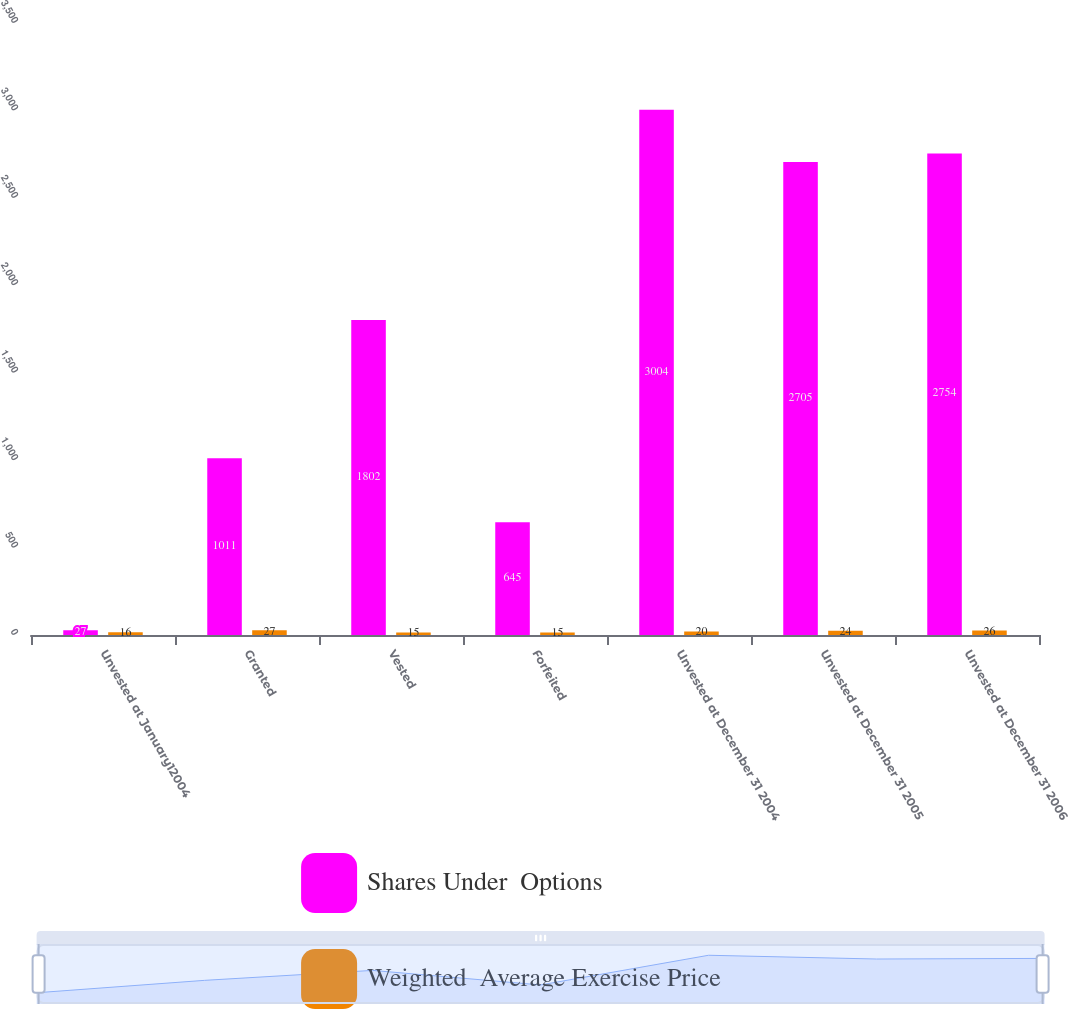<chart> <loc_0><loc_0><loc_500><loc_500><stacked_bar_chart><ecel><fcel>Unvested at January12004<fcel>Granted<fcel>Vested<fcel>Forfeited<fcel>Unvested at December 31 2004<fcel>Unvested at December 31 2005<fcel>Unvested at December 31 2006<nl><fcel>Shares Under  Options<fcel>27<fcel>1011<fcel>1802<fcel>645<fcel>3004<fcel>2705<fcel>2754<nl><fcel>Weighted  Average Exercise Price<fcel>16<fcel>27<fcel>15<fcel>15<fcel>20<fcel>24<fcel>26<nl></chart> 